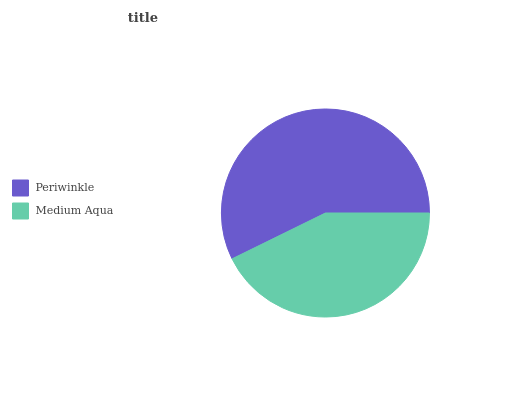Is Medium Aqua the minimum?
Answer yes or no. Yes. Is Periwinkle the maximum?
Answer yes or no. Yes. Is Medium Aqua the maximum?
Answer yes or no. No. Is Periwinkle greater than Medium Aqua?
Answer yes or no. Yes. Is Medium Aqua less than Periwinkle?
Answer yes or no. Yes. Is Medium Aqua greater than Periwinkle?
Answer yes or no. No. Is Periwinkle less than Medium Aqua?
Answer yes or no. No. Is Periwinkle the high median?
Answer yes or no. Yes. Is Medium Aqua the low median?
Answer yes or no. Yes. Is Medium Aqua the high median?
Answer yes or no. No. Is Periwinkle the low median?
Answer yes or no. No. 